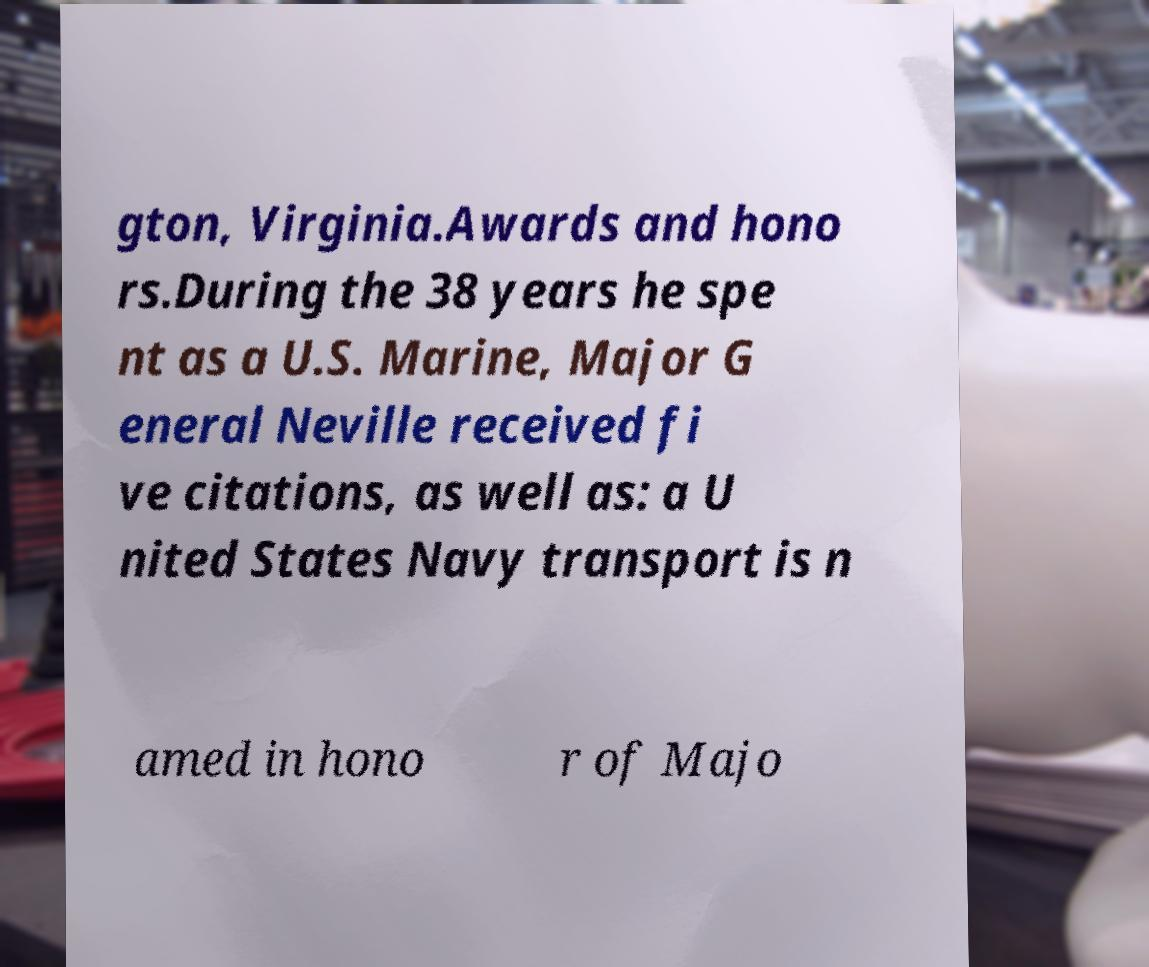Could you extract and type out the text from this image? gton, Virginia.Awards and hono rs.During the 38 years he spe nt as a U.S. Marine, Major G eneral Neville received fi ve citations, as well as: a U nited States Navy transport is n amed in hono r of Majo 